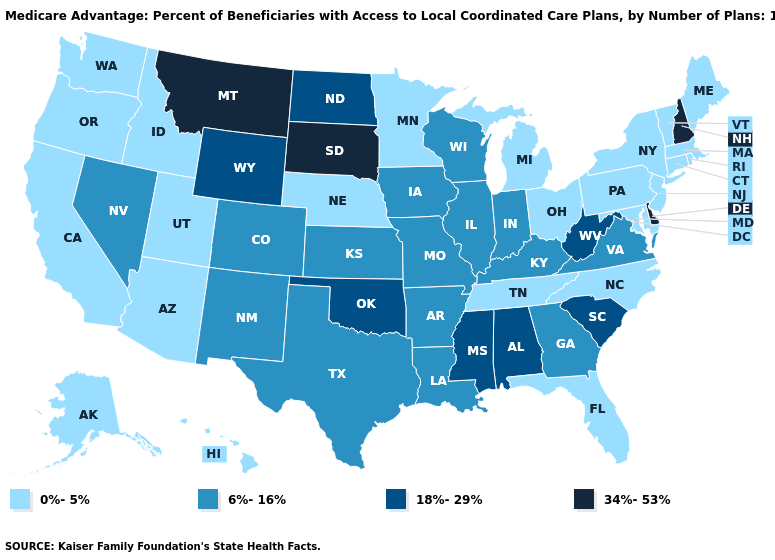What is the value of North Dakota?
Keep it brief. 18%-29%. What is the lowest value in the South?
Concise answer only. 0%-5%. Is the legend a continuous bar?
Keep it brief. No. Does the first symbol in the legend represent the smallest category?
Write a very short answer. Yes. Name the states that have a value in the range 34%-53%?
Be succinct. Delaware, Montana, New Hampshire, South Dakota. Does Rhode Island have the highest value in the Northeast?
Quick response, please. No. What is the value of Alabama?
Concise answer only. 18%-29%. Name the states that have a value in the range 6%-16%?
Quick response, please. Arkansas, Colorado, Georgia, Iowa, Illinois, Indiana, Kansas, Kentucky, Louisiana, Missouri, New Mexico, Nevada, Texas, Virginia, Wisconsin. What is the highest value in the USA?
Quick response, please. 34%-53%. What is the lowest value in the MidWest?
Quick response, please. 0%-5%. What is the lowest value in the USA?
Write a very short answer. 0%-5%. What is the lowest value in the West?
Answer briefly. 0%-5%. Which states hav the highest value in the West?
Quick response, please. Montana. What is the lowest value in the Northeast?
Quick response, please. 0%-5%. Among the states that border Tennessee , which have the lowest value?
Short answer required. North Carolina. 